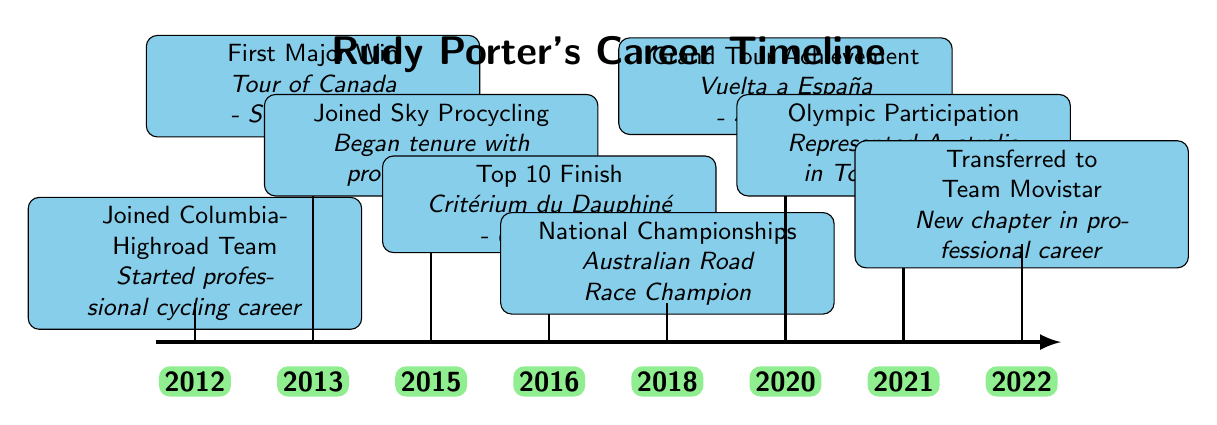What year did Rudy Porter join the Columbia-Highroad Team? The diagram indicates that Rudy Porter joined the Columbia-Highroad Team in 2012, as stated at the beginning of the timeline.
Answer: 2012 How many major achievements are listed in Rudy Porter's career timeline? By counting the individual achievements outlined in the timeline, there are a total of eight major achievements presented.
Answer: 8 What was Rudy Porter's first major win? The diagram specifies that Rudy Porter's first major win was at the Tour of Canada with a stage victory in 2013, the event listed after joining Columbia-Highroad Team.
Answer: Tour of Canada - Stage Victory Which year did Rudy Porter have a Top 10 finish in the Critérium du Dauphiné? According to the timeline, Rudy Porter achieved a Top 10 finish in 2016 at the Critérium du Dauphiné, as noted in the appropriate node on the timeline.
Answer: 2016 What was the most recent achievement in Rudy Porter's career timeline? The last achievement mentioned on the timeline is his transfer to Team Movistar in 2022, which marks the latest event in the timeline.
Answer: Transferred to Team Movistar In which Olympic Games did Rudy Porter represent Australia? The diagram details that Rudy Porter represented Australia in the Tokyo Olympics, which occurred in 2021, according to the relevant timeline entry.
Answer: Tokyo Olympics Which cycling team did Rudy Porter join in 2015? The timeline shows that Rudy Porter joined Sky Procycling in 2015, reflecting a significant change in his cycling career at that point.
Answer: Sky Procycling What event does the timeline highlight as Rudy Porter's achievement in 2018? The diagram indicates that in 2018, Rudy Porter became the Australian Road Race Champion, spotlighting his national title victory in that year.
Answer: Australian Road Race Champion 